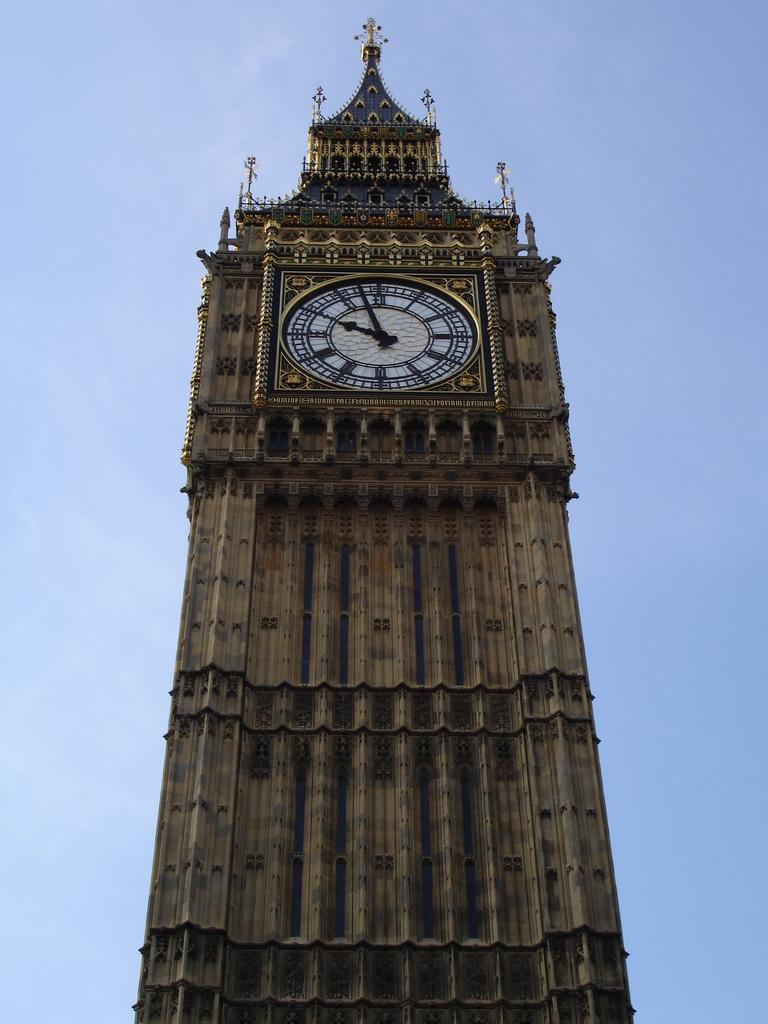What is the main structure in the picture? There is a clock tower in the picture. What can be seen at the top of the picture? The sky is visible at the top of the picture. How would you describe the sky in the picture? The sky is clear and blue. What type of secretary is working in the clock tower in the image? There is no secretary present in the image; it only features a clock tower and the sky. 